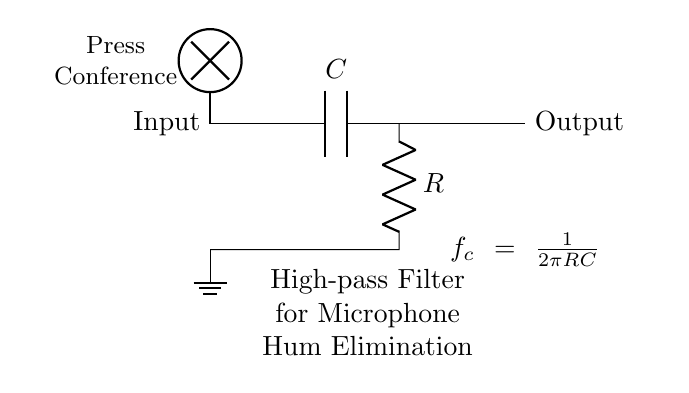What type of filter is depicted in the circuit? The circuit diagram illustrates a high-pass filter, identified by the arrangement of a capacitor and resistor. In high-pass filters, the output allows high-frequency signals to pass while attenuating low-frequency components.
Answer: high-pass filter What is the function of the capacitor in this circuit? The capacitor blocks low-frequency signals, which is a key characteristic of high-pass filters. It allows higher frequency signals to pass through while reducing the amplitude of lower frequency signals.
Answer: block low-frequency signals What component connects the input to the output in this circuit? The connection from the input to the output is made through the capacitor and resistor configuration. The capacitor is directly connected to the output node, allowing specific frequencies to pass through based on the cutoff frequency defined by the resistor and capacitor values.
Answer: capacitor What is the formula for the cutoff frequency of this filter? The cutoff frequency formula is derived from the configuration of the circuit, specifically from the values of the resistor and capacitor. It can be expressed as \( f_c = \frac{1}{2\pi RC} \), determining the frequency at which the output signal begins to roll off.
Answer: f_c = 1 / 2πRC How does changing the resistance value affect the cutoff frequency? Increasing the resistance value will lead to a decrease in the cutoff frequency according to the formula, as the product \( RC \) will increase. This means that lower frequencies will now be allowed to pass through, impacting the filter's performance in eliminating low-frequency hum.
Answer: decreases cutoff frequency What is the role of the ground in this circuit? The ground serves as a reference point for the circuit, providing a common return path for current. It establishes a baseline voltage, which is crucial for ensuring that voltages across other components are measured relative to a stable reference, thereby aiding in proper circuit operation.
Answer: reference point What is the significance of using a high-pass filter in a microphone application during press conferences? A high-pass filter in microphone applications is significant as it effectively eliminates low-frequency noise such as hum or rumble, enhancing the clarity of the voice or sound being captured during press conferences. This results in a cleaner audio signal suitable for dissemination.
Answer: eliminates low-frequency noise 